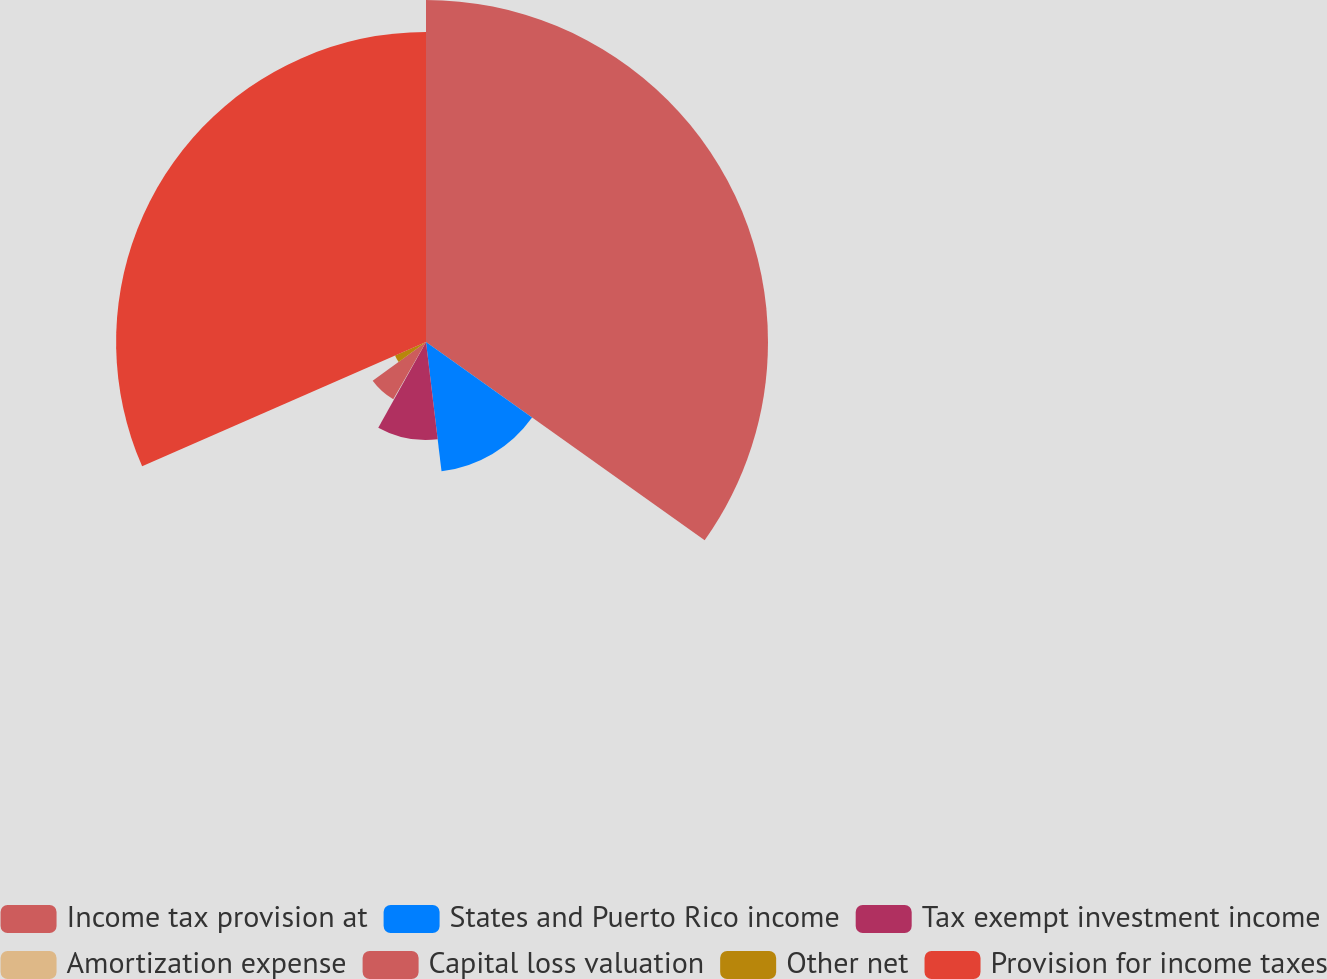Convert chart. <chart><loc_0><loc_0><loc_500><loc_500><pie_chart><fcel>Income tax provision at<fcel>States and Puerto Rico income<fcel>Tax exempt investment income<fcel>Amortization expense<fcel>Capital loss valuation<fcel>Other net<fcel>Provision for income taxes<nl><fcel>34.84%<fcel>13.26%<fcel>9.99%<fcel>0.17%<fcel>6.72%<fcel>3.45%<fcel>31.57%<nl></chart> 